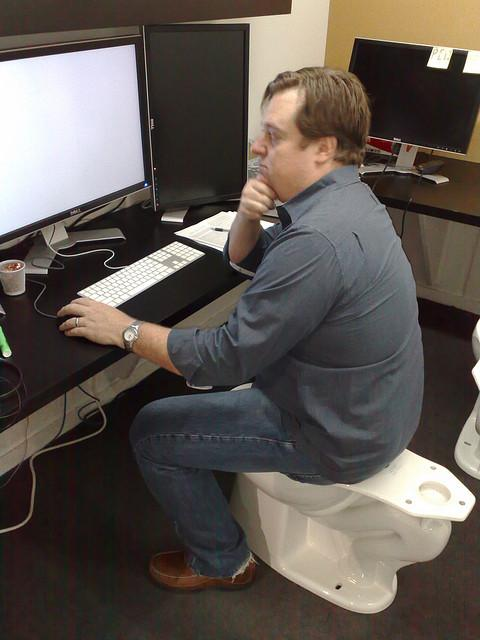What part of this mans furniture is most surprising? toilet 